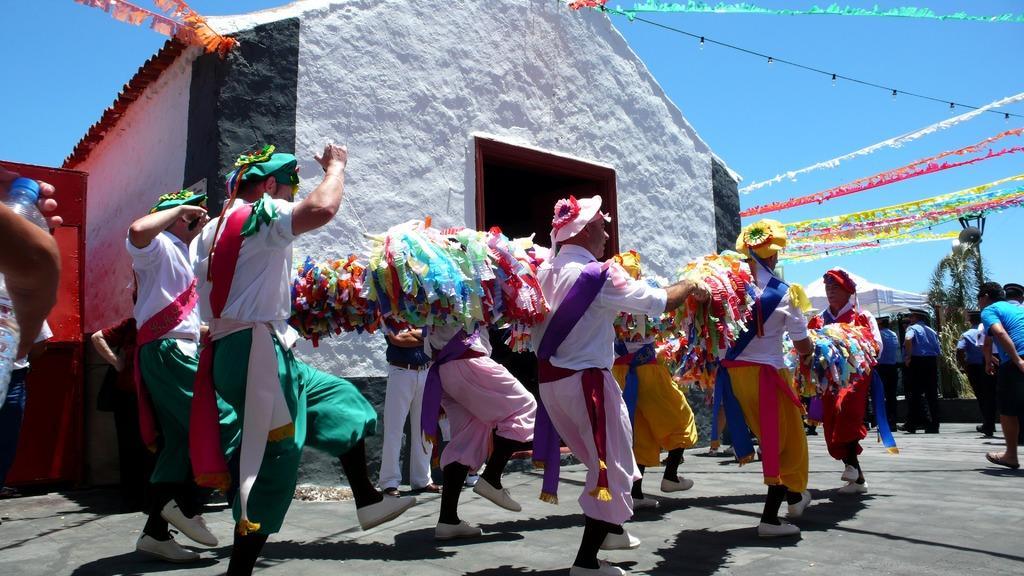In one or two sentences, can you explain what this image depicts? In this image we can see group of people standing on ground wearing different dresses. In the background we can see tree ,shed ,ribbons ,a building and the sky. 